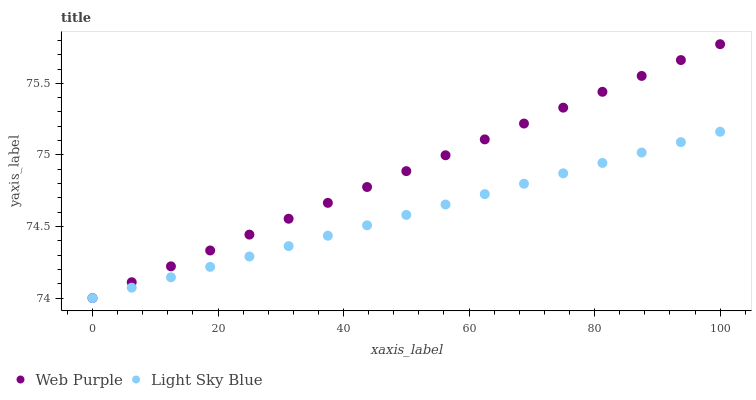Does Light Sky Blue have the minimum area under the curve?
Answer yes or no. Yes. Does Web Purple have the maximum area under the curve?
Answer yes or no. Yes. Does Light Sky Blue have the maximum area under the curve?
Answer yes or no. No. Is Light Sky Blue the smoothest?
Answer yes or no. Yes. Is Web Purple the roughest?
Answer yes or no. Yes. Is Light Sky Blue the roughest?
Answer yes or no. No. Does Web Purple have the lowest value?
Answer yes or no. Yes. Does Web Purple have the highest value?
Answer yes or no. Yes. Does Light Sky Blue have the highest value?
Answer yes or no. No. Does Light Sky Blue intersect Web Purple?
Answer yes or no. Yes. Is Light Sky Blue less than Web Purple?
Answer yes or no. No. Is Light Sky Blue greater than Web Purple?
Answer yes or no. No. 